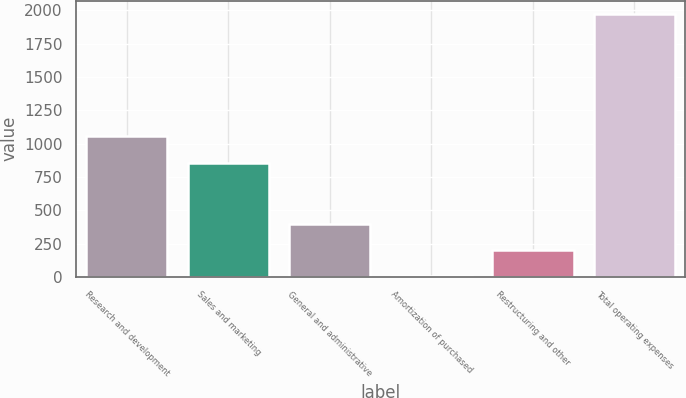Convert chart. <chart><loc_0><loc_0><loc_500><loc_500><bar_chart><fcel>Research and development<fcel>Sales and marketing<fcel>General and administrative<fcel>Amortization of purchased<fcel>Restructuring and other<fcel>Total operating expenses<nl><fcel>1054.1<fcel>857.1<fcel>398.2<fcel>4.2<fcel>201.2<fcel>1974.2<nl></chart> 